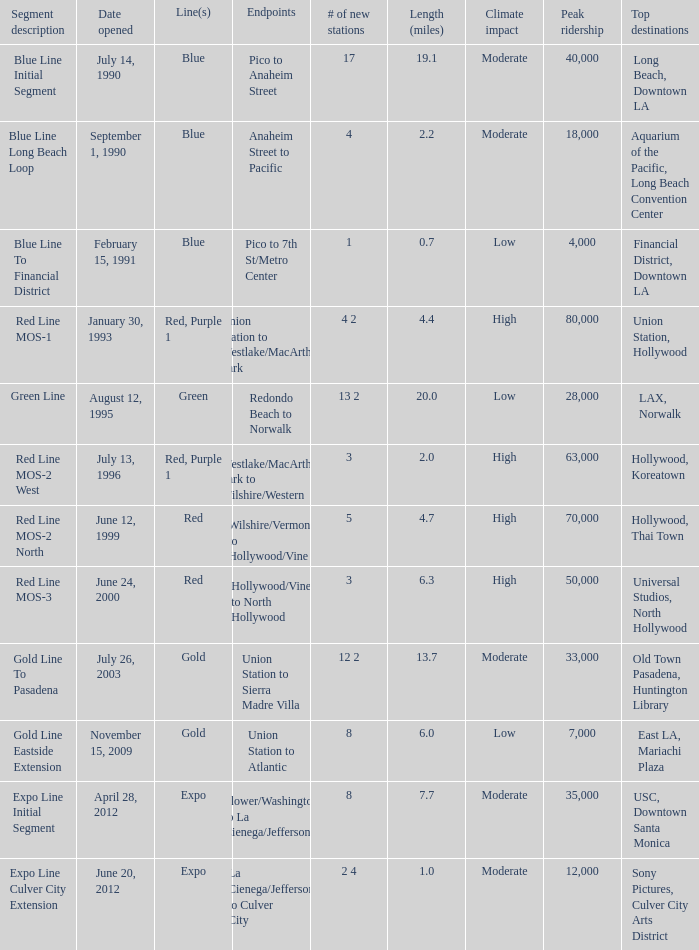What is the lenth (miles) of endpoints westlake/macarthur park to wilshire/western? 2.0. 